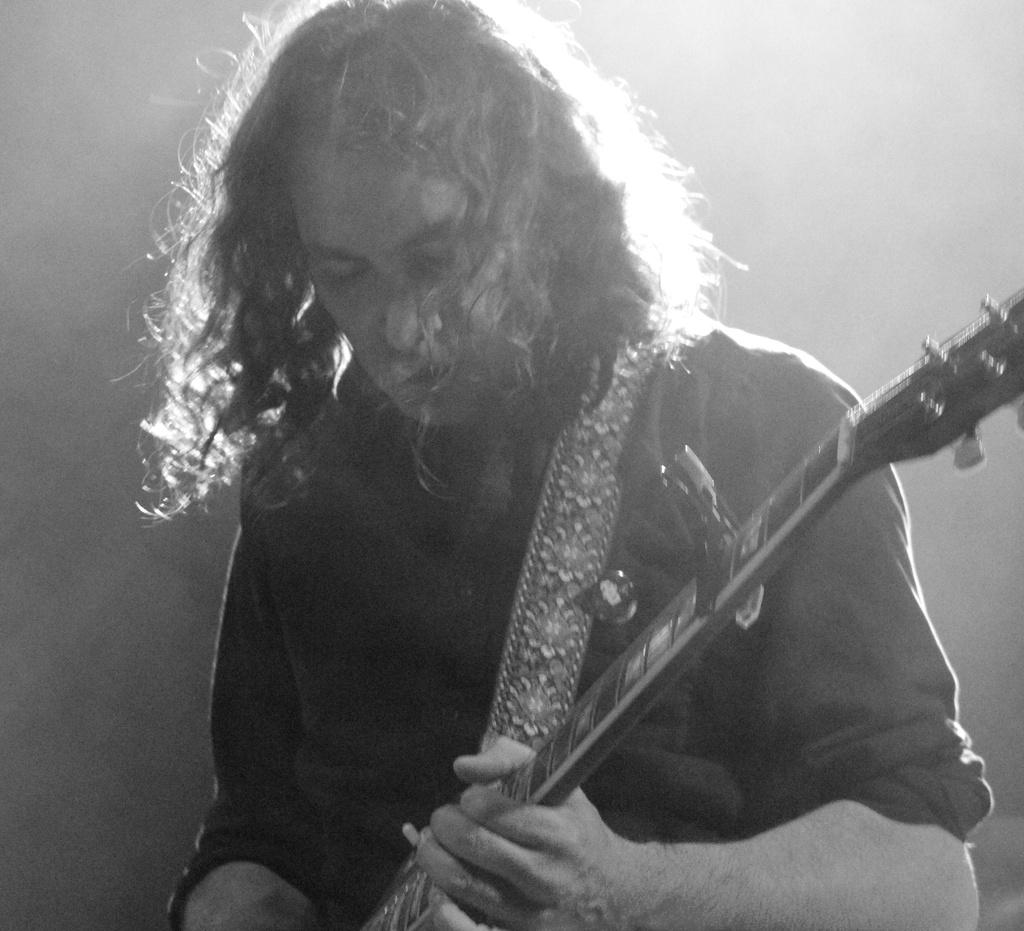What is the main subject of the image? The main subject of the image is a man. What is the man doing in the image? The man is playing a guitar in the image. What type of cart can be seen in the background of the image? There is no cart present in the image; it only features a man playing a guitar. What subject is being taught in the class depicted in the image? There is no class or subject being taught in the image; it only features a man playing a guitar. 